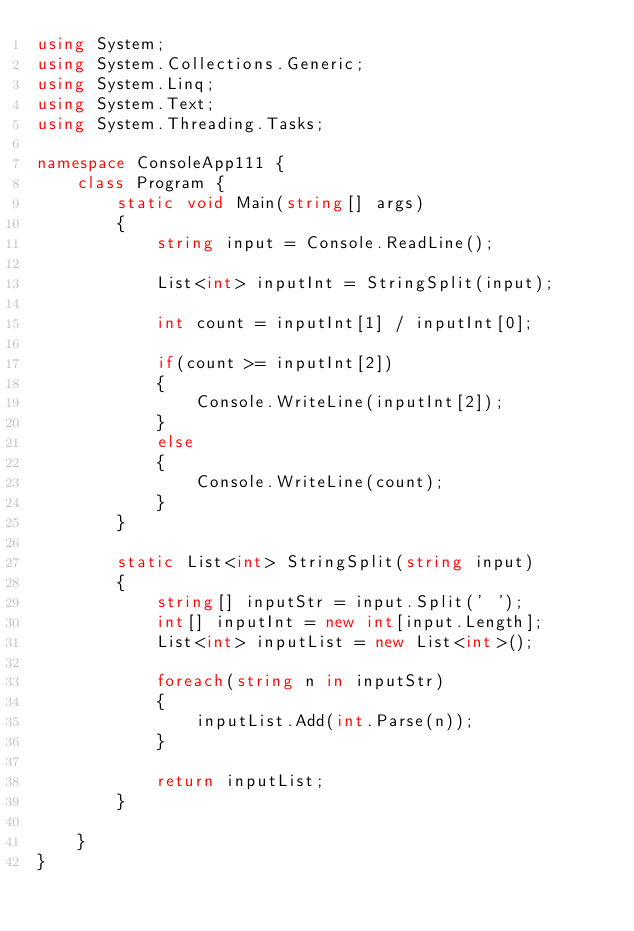Convert code to text. <code><loc_0><loc_0><loc_500><loc_500><_C#_>using System;
using System.Collections.Generic;
using System.Linq;
using System.Text;
using System.Threading.Tasks;

namespace ConsoleApp111 {
    class Program {
        static void Main(string[] args)
        {
            string input = Console.ReadLine();

            List<int> inputInt = StringSplit(input);

            int count = inputInt[1] / inputInt[0];

            if(count >= inputInt[2])
            {
                Console.WriteLine(inputInt[2]);
            }
            else
            {
                Console.WriteLine(count);
            }
        }

        static List<int> StringSplit(string input)
        {
            string[] inputStr = input.Split(' ');
            int[] inputInt = new int[input.Length];
            List<int> inputList = new List<int>();

            foreach(string n in inputStr)
            {
                inputList.Add(int.Parse(n));
            }

            return inputList;
        }
        
    }
}</code> 